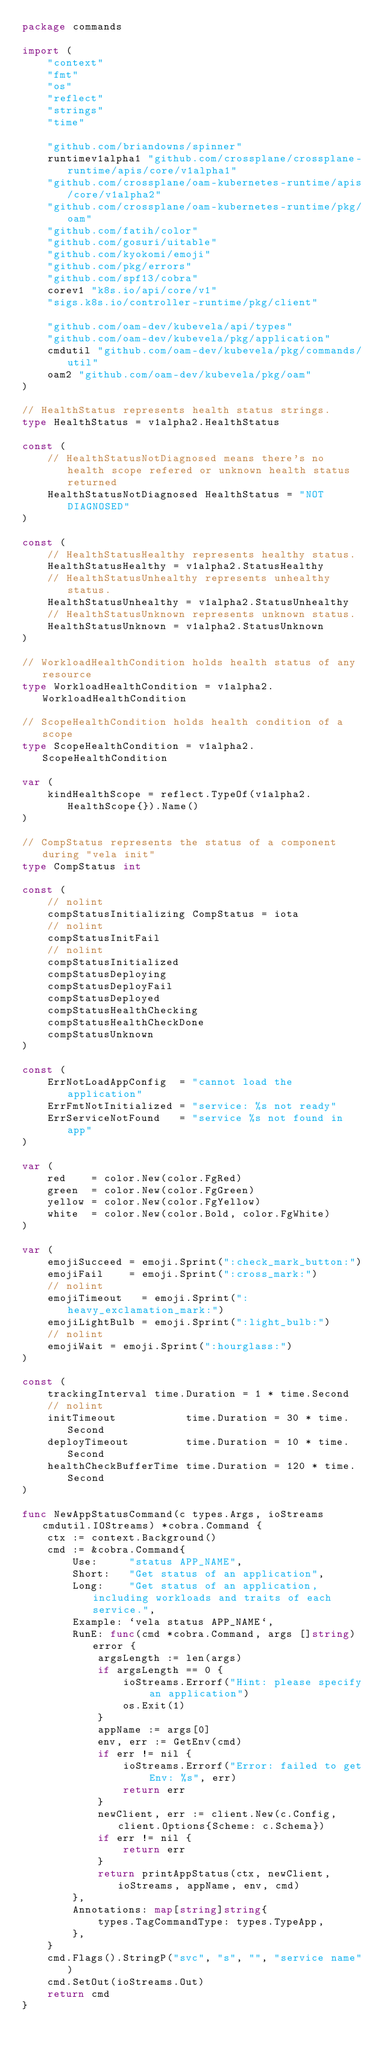Convert code to text. <code><loc_0><loc_0><loc_500><loc_500><_Go_>package commands

import (
	"context"
	"fmt"
	"os"
	"reflect"
	"strings"
	"time"

	"github.com/briandowns/spinner"
	runtimev1alpha1 "github.com/crossplane/crossplane-runtime/apis/core/v1alpha1"
	"github.com/crossplane/oam-kubernetes-runtime/apis/core/v1alpha2"
	"github.com/crossplane/oam-kubernetes-runtime/pkg/oam"
	"github.com/fatih/color"
	"github.com/gosuri/uitable"
	"github.com/kyokomi/emoji"
	"github.com/pkg/errors"
	"github.com/spf13/cobra"
	corev1 "k8s.io/api/core/v1"
	"sigs.k8s.io/controller-runtime/pkg/client"

	"github.com/oam-dev/kubevela/api/types"
	"github.com/oam-dev/kubevela/pkg/application"
	cmdutil "github.com/oam-dev/kubevela/pkg/commands/util"
	oam2 "github.com/oam-dev/kubevela/pkg/oam"
)

// HealthStatus represents health status strings.
type HealthStatus = v1alpha2.HealthStatus

const (
	// HealthStatusNotDiagnosed means there's no health scope refered or unknown health status returned
	HealthStatusNotDiagnosed HealthStatus = "NOT DIAGNOSED"
)

const (
	// HealthStatusHealthy represents healthy status.
	HealthStatusHealthy = v1alpha2.StatusHealthy
	// HealthStatusUnhealthy represents unhealthy status.
	HealthStatusUnhealthy = v1alpha2.StatusUnhealthy
	// HealthStatusUnknown represents unknown status.
	HealthStatusUnknown = v1alpha2.StatusUnknown
)

// WorkloadHealthCondition holds health status of any resource
type WorkloadHealthCondition = v1alpha2.WorkloadHealthCondition

// ScopeHealthCondition holds health condition of a scope
type ScopeHealthCondition = v1alpha2.ScopeHealthCondition

var (
	kindHealthScope = reflect.TypeOf(v1alpha2.HealthScope{}).Name()
)

// CompStatus represents the status of a component during "vela init"
type CompStatus int

const (
	// nolint
	compStatusInitializing CompStatus = iota
	// nolint
	compStatusInitFail
	// nolint
	compStatusInitialized
	compStatusDeploying
	compStatusDeployFail
	compStatusDeployed
	compStatusHealthChecking
	compStatusHealthCheckDone
	compStatusUnknown
)

const (
	ErrNotLoadAppConfig  = "cannot load the application"
	ErrFmtNotInitialized = "service: %s not ready"
	ErrServiceNotFound   = "service %s not found in app"
)

var (
	red    = color.New(color.FgRed)
	green  = color.New(color.FgGreen)
	yellow = color.New(color.FgYellow)
	white  = color.New(color.Bold, color.FgWhite)
)

var (
	emojiSucceed = emoji.Sprint(":check_mark_button:")
	emojiFail    = emoji.Sprint(":cross_mark:")
	// nolint
	emojiTimeout   = emoji.Sprint(":heavy_exclamation_mark:")
	emojiLightBulb = emoji.Sprint(":light_bulb:")
	// nolint
	emojiWait = emoji.Sprint(":hourglass:")
)

const (
	trackingInterval time.Duration = 1 * time.Second
	// nolint
	initTimeout           time.Duration = 30 * time.Second
	deployTimeout         time.Duration = 10 * time.Second
	healthCheckBufferTime time.Duration = 120 * time.Second
)

func NewAppStatusCommand(c types.Args, ioStreams cmdutil.IOStreams) *cobra.Command {
	ctx := context.Background()
	cmd := &cobra.Command{
		Use:     "status APP_NAME",
		Short:   "Get status of an application",
		Long:    "Get status of an application, including workloads and traits of each service.",
		Example: `vela status APP_NAME`,
		RunE: func(cmd *cobra.Command, args []string) error {
			argsLength := len(args)
			if argsLength == 0 {
				ioStreams.Errorf("Hint: please specify an application")
				os.Exit(1)
			}
			appName := args[0]
			env, err := GetEnv(cmd)
			if err != nil {
				ioStreams.Errorf("Error: failed to get Env: %s", err)
				return err
			}
			newClient, err := client.New(c.Config, client.Options{Scheme: c.Schema})
			if err != nil {
				return err
			}
			return printAppStatus(ctx, newClient, ioStreams, appName, env, cmd)
		},
		Annotations: map[string]string{
			types.TagCommandType: types.TypeApp,
		},
	}
	cmd.Flags().StringP("svc", "s", "", "service name")
	cmd.SetOut(ioStreams.Out)
	return cmd
}
</code> 